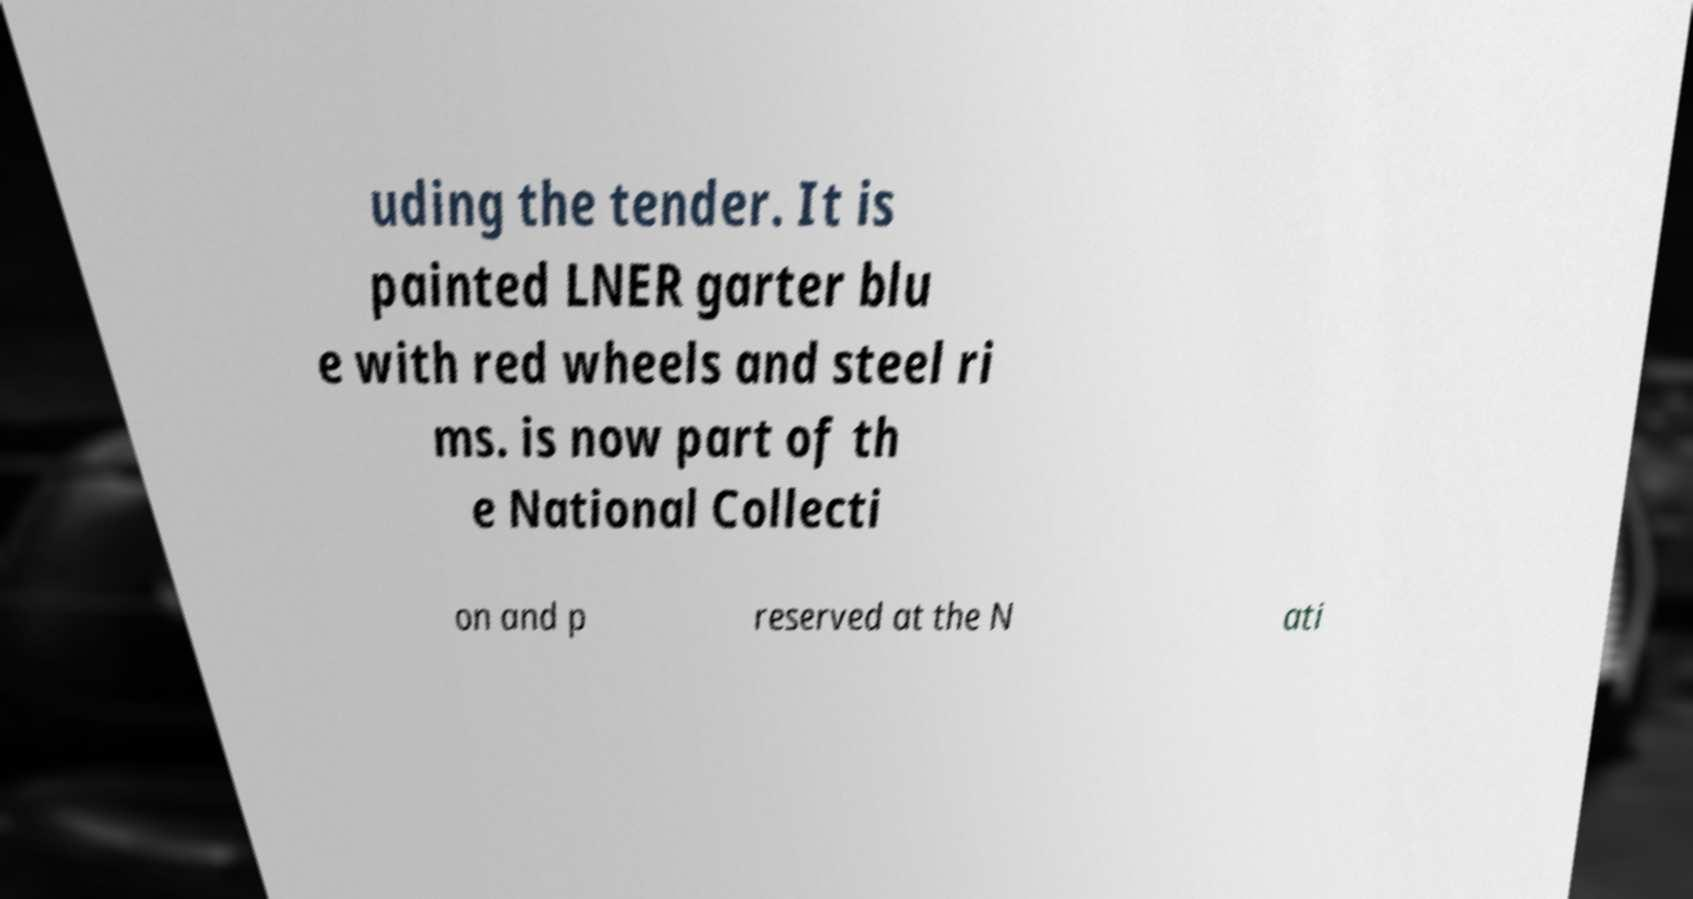Can you read and provide the text displayed in the image?This photo seems to have some interesting text. Can you extract and type it out for me? uding the tender. It is painted LNER garter blu e with red wheels and steel ri ms. is now part of th e National Collecti on and p reserved at the N ati 